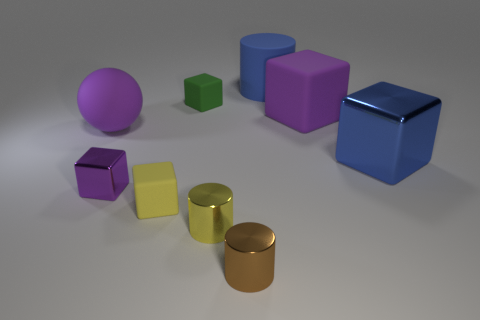Subtract all green blocks. How many blocks are left? 4 Subtract all green matte blocks. How many blocks are left? 4 Subtract all brown blocks. Subtract all brown cylinders. How many blocks are left? 5 Subtract all cylinders. How many objects are left? 6 Subtract all tiny metallic objects. Subtract all green objects. How many objects are left? 5 Add 4 tiny objects. How many tiny objects are left? 9 Add 8 large blue shiny things. How many large blue shiny things exist? 9 Subtract 0 cyan cylinders. How many objects are left? 9 